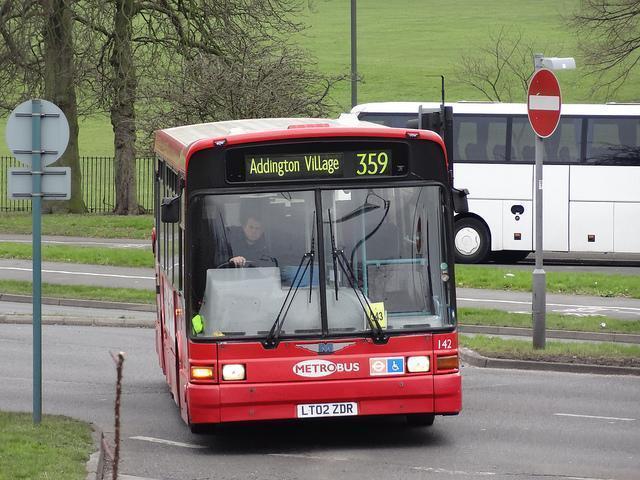What type of information is on the digital bus sign?
Select the accurate response from the four choices given to answer the question.
Options: Brand, informational, directional, warning. Informational. 